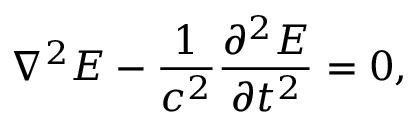Convert formula to latex. <formula><loc_0><loc_0><loc_500><loc_500>\nabla ^ { 2 } E - \frac { 1 } { c ^ { 2 } } \frac { \partial ^ { 2 } E } { \partial t ^ { 2 } } = 0 ,</formula> 